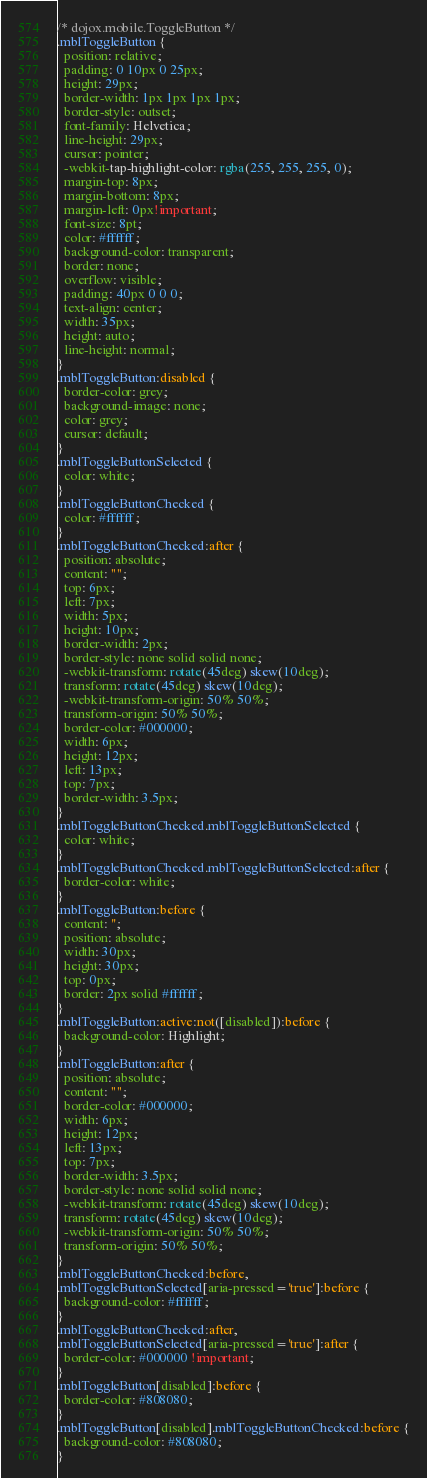<code> <loc_0><loc_0><loc_500><loc_500><_CSS_>/* dojox.mobile.ToggleButton */
.mblToggleButton {
  position: relative;
  padding: 0 10px 0 25px;
  height: 29px;
  border-width: 1px 1px 1px 1px;
  border-style: outset;
  font-family: Helvetica;
  line-height: 29px;
  cursor: pointer;
  -webkit-tap-highlight-color: rgba(255, 255, 255, 0);
  margin-top: 8px;
  margin-bottom: 8px;
  margin-left: 0px!important;
  font-size: 8pt;
  color: #ffffff;
  background-color: transparent;
  border: none;
  overflow: visible;
  padding: 40px 0 0 0;
  text-align: center;
  width: 35px;
  height: auto;
  line-height: normal;
}
.mblToggleButton:disabled {
  border-color: grey;
  background-image: none;
  color: grey;
  cursor: default;
}
.mblToggleButtonSelected {
  color: white;
}
.mblToggleButtonChecked {
  color: #ffffff;
}
.mblToggleButtonChecked:after {
  position: absolute;
  content: "";
  top: 6px;
  left: 7px;
  width: 5px;
  height: 10px;
  border-width: 2px;
  border-style: none solid solid none;
  -webkit-transform: rotate(45deg) skew(10deg);
  transform: rotate(45deg) skew(10deg);
  -webkit-transform-origin: 50% 50%;
  transform-origin: 50% 50%;
  border-color: #000000;
  width: 6px;
  height: 12px;
  left: 13px;
  top: 7px;
  border-width: 3.5px;
}
.mblToggleButtonChecked.mblToggleButtonSelected {
  color: white;
}
.mblToggleButtonChecked.mblToggleButtonSelected:after {
  border-color: white;
}
.mblToggleButton:before {
  content: '';
  position: absolute;
  width: 30px;
  height: 30px;
  top: 0px;
  border: 2px solid #ffffff;
}
.mblToggleButton:active:not([disabled]):before {
  background-color: Highlight;
}
.mblToggleButton:after {
  position: absolute;
  content: "";
  border-color: #000000;
  width: 6px;
  height: 12px;
  left: 13px;
  top: 7px;
  border-width: 3.5px;
  border-style: none solid solid none;
  -webkit-transform: rotate(45deg) skew(10deg);
  transform: rotate(45deg) skew(10deg);
  -webkit-transform-origin: 50% 50%;
  transform-origin: 50% 50%;
}
.mblToggleButtonChecked:before,
.mblToggleButtonSelected[aria-pressed='true']:before {
  background-color: #ffffff;
}
.mblToggleButtonChecked:after,
.mblToggleButtonSelected[aria-pressed='true']:after {
  border-color: #000000 !important;
}
.mblToggleButton[disabled]:before {
  border-color: #808080;
}
.mblToggleButton[disabled].mblToggleButtonChecked:before {
  background-color: #808080;
}
</code> 